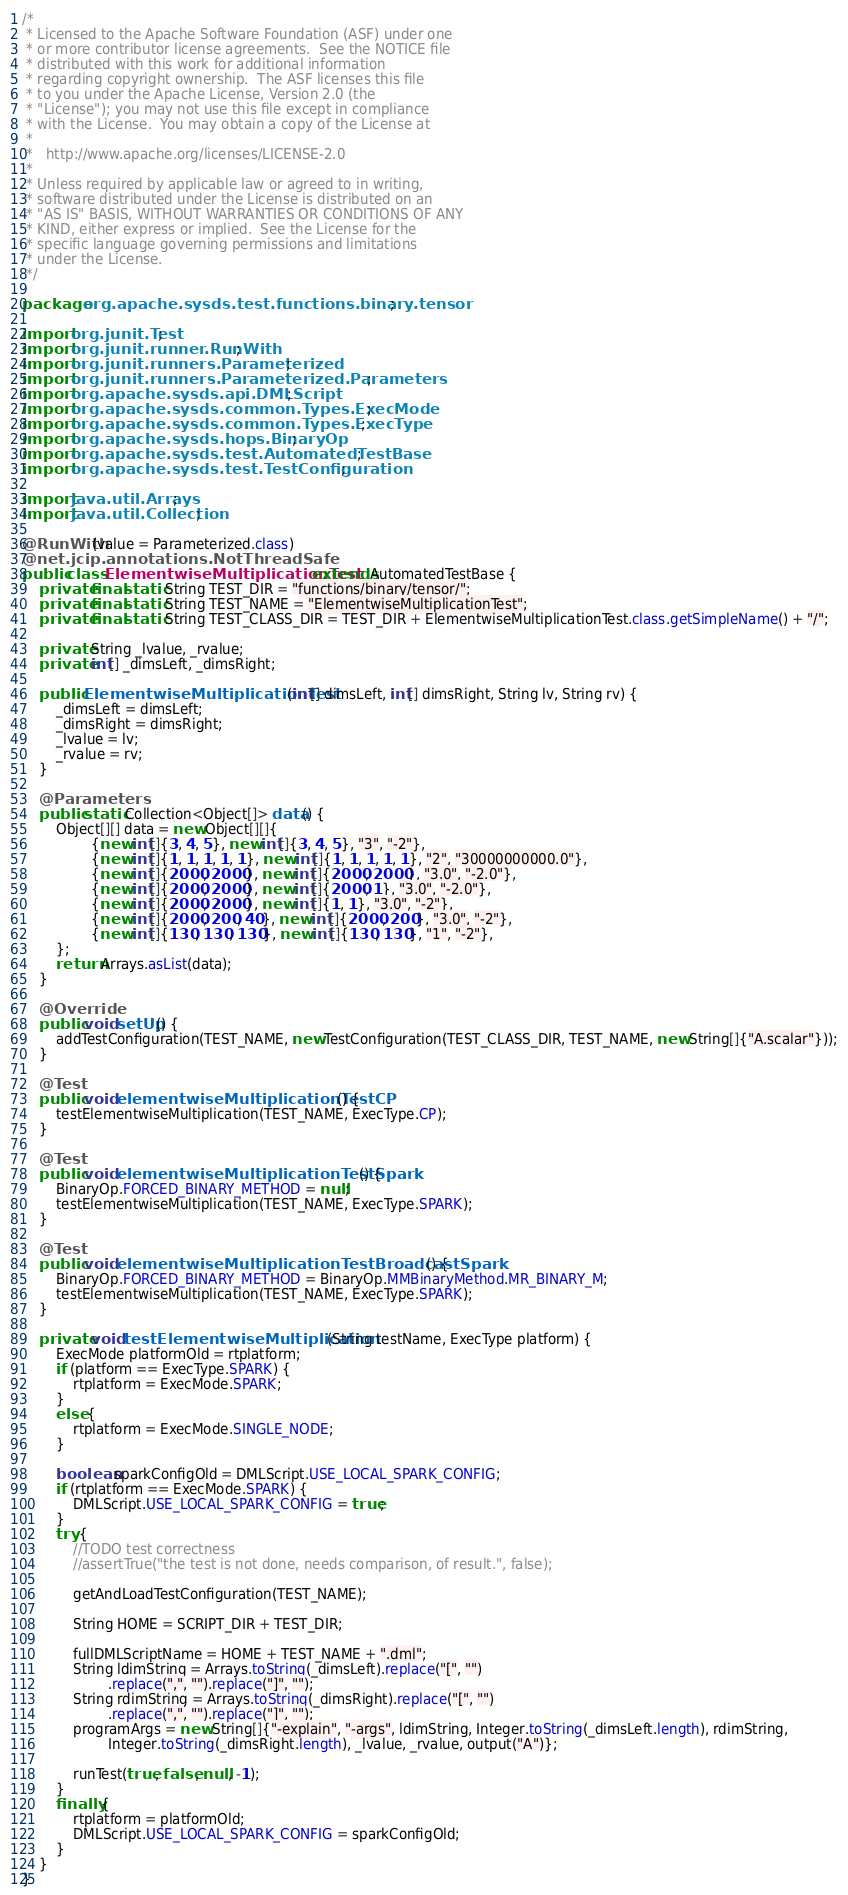Convert code to text. <code><loc_0><loc_0><loc_500><loc_500><_Java_>/*
 * Licensed to the Apache Software Foundation (ASF) under one
 * or more contributor license agreements.  See the NOTICE file
 * distributed with this work for additional information
 * regarding copyright ownership.  The ASF licenses this file
 * to you under the Apache License, Version 2.0 (the
 * "License"); you may not use this file except in compliance
 * with the License.  You may obtain a copy of the License at
 *
 *   http://www.apache.org/licenses/LICENSE-2.0
 *
 * Unless required by applicable law or agreed to in writing,
 * software distributed under the License is distributed on an
 * "AS IS" BASIS, WITHOUT WARRANTIES OR CONDITIONS OF ANY
 * KIND, either express or implied.  See the License for the
 * specific language governing permissions and limitations
 * under the License.
 */

package org.apache.sysds.test.functions.binary.tensor;

import org.junit.Test;
import org.junit.runner.RunWith;
import org.junit.runners.Parameterized;
import org.junit.runners.Parameterized.Parameters;
import org.apache.sysds.api.DMLScript;
import org.apache.sysds.common.Types.ExecMode;
import org.apache.sysds.common.Types.ExecType;
import org.apache.sysds.hops.BinaryOp;
import org.apache.sysds.test.AutomatedTestBase;
import org.apache.sysds.test.TestConfiguration;

import java.util.Arrays;
import java.util.Collection;

@RunWith(value = Parameterized.class)
@net.jcip.annotations.NotThreadSafe
public class ElementwiseMultiplicationTest extends AutomatedTestBase {
	private final static String TEST_DIR = "functions/binary/tensor/";
	private final static String TEST_NAME = "ElementwiseMultiplicationTest";
	private final static String TEST_CLASS_DIR = TEST_DIR + ElementwiseMultiplicationTest.class.getSimpleName() + "/";

	private String _lvalue, _rvalue;
	private int[] _dimsLeft, _dimsRight;

	public ElementwiseMultiplicationTest(int[] dimsLeft, int[] dimsRight, String lv, String rv) {
		_dimsLeft = dimsLeft;
		_dimsRight = dimsRight;
		_lvalue = lv;
		_rvalue = rv;
	}

	@Parameters
	public static Collection<Object[]> data() {
		Object[][] data = new Object[][]{
				{new int[]{3, 4, 5}, new int[]{3, 4, 5}, "3", "-2"},
				{new int[]{1, 1, 1, 1, 1}, new int[]{1, 1, 1, 1, 1}, "2", "30000000000.0"},
				{new int[]{2000, 2000}, new int[]{2000, 2000}, "3.0", "-2.0"},
				{new int[]{2000, 2000}, new int[]{2000, 1}, "3.0", "-2.0"},
				{new int[]{2000, 2000}, new int[]{1, 1}, "3.0", "-2"},
				{new int[]{2000, 200, 40}, new int[]{2000, 200}, "3.0", "-2"},
				{new int[]{130, 130, 130}, new int[]{130, 130}, "1", "-2"},
		};
		return Arrays.asList(data);
	}

	@Override
	public void setUp() {
		addTestConfiguration(TEST_NAME, new TestConfiguration(TEST_CLASS_DIR, TEST_NAME, new String[]{"A.scalar"}));
	}

	@Test
	public void elementwiseMultiplicationTestCP() {
		testElementwiseMultiplication(TEST_NAME, ExecType.CP);
	}

	@Test
	public void elementwiseMultiplicationTestSpark() {
		BinaryOp.FORCED_BINARY_METHOD = null;
		testElementwiseMultiplication(TEST_NAME, ExecType.SPARK);
	}

	@Test
	public void elementwiseMultiplicationTestBroadcastSpark() {
		BinaryOp.FORCED_BINARY_METHOD = BinaryOp.MMBinaryMethod.MR_BINARY_M;
		testElementwiseMultiplication(TEST_NAME, ExecType.SPARK);
	}

	private void testElementwiseMultiplication(String testName, ExecType platform) {
		ExecMode platformOld = rtplatform;
		if (platform == ExecType.SPARK) {
			rtplatform = ExecMode.SPARK;
		}
		else {
			rtplatform = ExecMode.SINGLE_NODE;
		}

		boolean sparkConfigOld = DMLScript.USE_LOCAL_SPARK_CONFIG;
		if (rtplatform == ExecMode.SPARK) {
			DMLScript.USE_LOCAL_SPARK_CONFIG = true;
		}
		try {
			//TODO test correctness
			//assertTrue("the test is not done, needs comparison, of result.", false);

			getAndLoadTestConfiguration(TEST_NAME);

			String HOME = SCRIPT_DIR + TEST_DIR;

			fullDMLScriptName = HOME + TEST_NAME + ".dml";
			String ldimString = Arrays.toString(_dimsLeft).replace("[", "")
					.replace(",", "").replace("]", "");
			String rdimString = Arrays.toString(_dimsRight).replace("[", "")
					.replace(",", "").replace("]", "");
			programArgs = new String[]{"-explain", "-args", ldimString, Integer.toString(_dimsLeft.length), rdimString,
					Integer.toString(_dimsRight.length), _lvalue, _rvalue, output("A")};

			runTest(true, false, null, -1);
		}
		finally {
			rtplatform = platformOld;
			DMLScript.USE_LOCAL_SPARK_CONFIG = sparkConfigOld;
		}
	}
}
</code> 